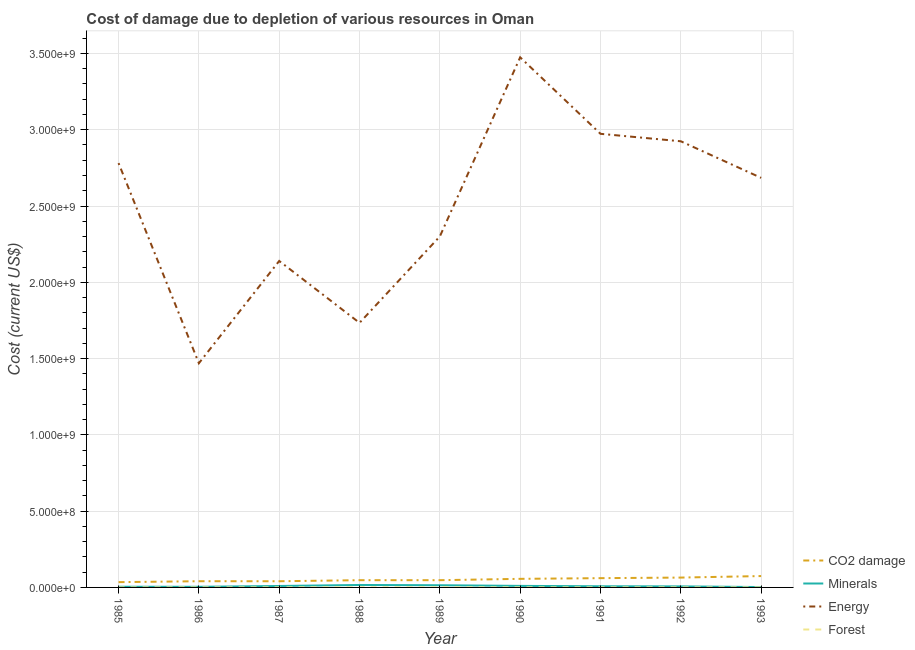How many different coloured lines are there?
Keep it short and to the point. 4. Does the line corresponding to cost of damage due to depletion of forests intersect with the line corresponding to cost of damage due to depletion of minerals?
Make the answer very short. No. What is the cost of damage due to depletion of energy in 1991?
Make the answer very short. 2.97e+09. Across all years, what is the maximum cost of damage due to depletion of minerals?
Make the answer very short. 1.61e+07. Across all years, what is the minimum cost of damage due to depletion of energy?
Offer a very short reply. 1.47e+09. In which year was the cost of damage due to depletion of coal maximum?
Make the answer very short. 1993. In which year was the cost of damage due to depletion of forests minimum?
Offer a terse response. 1985. What is the total cost of damage due to depletion of forests in the graph?
Your answer should be compact. 3.37e+06. What is the difference between the cost of damage due to depletion of energy in 1991 and that in 1993?
Make the answer very short. 2.89e+08. What is the difference between the cost of damage due to depletion of energy in 1993 and the cost of damage due to depletion of forests in 1986?
Give a very brief answer. 2.68e+09. What is the average cost of damage due to depletion of minerals per year?
Provide a succinct answer. 8.39e+06. In the year 1991, what is the difference between the cost of damage due to depletion of energy and cost of damage due to depletion of coal?
Provide a short and direct response. 2.91e+09. In how many years, is the cost of damage due to depletion of coal greater than 1200000000 US$?
Ensure brevity in your answer.  0. What is the ratio of the cost of damage due to depletion of minerals in 1986 to that in 1993?
Your answer should be very brief. 1.66. Is the cost of damage due to depletion of coal in 1985 less than that in 1988?
Your response must be concise. Yes. Is the difference between the cost of damage due to depletion of minerals in 1986 and 1988 greater than the difference between the cost of damage due to depletion of forests in 1986 and 1988?
Provide a short and direct response. No. What is the difference between the highest and the second highest cost of damage due to depletion of energy?
Provide a short and direct response. 5.01e+08. What is the difference between the highest and the lowest cost of damage due to depletion of forests?
Provide a succinct answer. 3.76e+05. In how many years, is the cost of damage due to depletion of minerals greater than the average cost of damage due to depletion of minerals taken over all years?
Make the answer very short. 4. Is it the case that in every year, the sum of the cost of damage due to depletion of coal and cost of damage due to depletion of minerals is greater than the cost of damage due to depletion of energy?
Your answer should be very brief. No. Is the cost of damage due to depletion of forests strictly greater than the cost of damage due to depletion of coal over the years?
Give a very brief answer. No. How many lines are there?
Make the answer very short. 4. How many years are there in the graph?
Provide a succinct answer. 9. Does the graph contain any zero values?
Offer a very short reply. No. How are the legend labels stacked?
Offer a terse response. Vertical. What is the title of the graph?
Provide a succinct answer. Cost of damage due to depletion of various resources in Oman . What is the label or title of the Y-axis?
Your response must be concise. Cost (current US$). What is the Cost (current US$) in CO2 damage in 1985?
Provide a succinct answer. 3.46e+07. What is the Cost (current US$) of Minerals in 1985?
Your response must be concise. 4.45e+06. What is the Cost (current US$) of Energy in 1985?
Give a very brief answer. 2.78e+09. What is the Cost (current US$) of Forest in 1985?
Give a very brief answer. 1.15e+05. What is the Cost (current US$) in CO2 damage in 1986?
Make the answer very short. 4.07e+07. What is the Cost (current US$) in Minerals in 1986?
Offer a terse response. 4.15e+06. What is the Cost (current US$) of Energy in 1986?
Provide a succinct answer. 1.47e+09. What is the Cost (current US$) in Forest in 1986?
Ensure brevity in your answer.  3.53e+05. What is the Cost (current US$) of CO2 damage in 1987?
Offer a terse response. 4.05e+07. What is the Cost (current US$) of Minerals in 1987?
Your answer should be very brief. 9.47e+06. What is the Cost (current US$) in Energy in 1987?
Offer a very short reply. 2.14e+09. What is the Cost (current US$) in Forest in 1987?
Provide a succinct answer. 3.85e+05. What is the Cost (current US$) of CO2 damage in 1988?
Provide a short and direct response. 4.74e+07. What is the Cost (current US$) of Minerals in 1988?
Your response must be concise. 1.61e+07. What is the Cost (current US$) in Energy in 1988?
Make the answer very short. 1.73e+09. What is the Cost (current US$) in Forest in 1988?
Your answer should be very brief. 4.10e+05. What is the Cost (current US$) in CO2 damage in 1989?
Keep it short and to the point. 4.74e+07. What is the Cost (current US$) in Minerals in 1989?
Provide a succinct answer. 1.43e+07. What is the Cost (current US$) of Energy in 1989?
Your response must be concise. 2.30e+09. What is the Cost (current US$) in Forest in 1989?
Offer a very short reply. 4.40e+05. What is the Cost (current US$) in CO2 damage in 1990?
Make the answer very short. 5.63e+07. What is the Cost (current US$) of Minerals in 1990?
Your answer should be very brief. 1.00e+07. What is the Cost (current US$) in Energy in 1990?
Your answer should be very brief. 3.47e+09. What is the Cost (current US$) of Forest in 1990?
Give a very brief answer. 4.68e+05. What is the Cost (current US$) of CO2 damage in 1991?
Keep it short and to the point. 6.08e+07. What is the Cost (current US$) of Minerals in 1991?
Ensure brevity in your answer.  7.56e+06. What is the Cost (current US$) of Energy in 1991?
Make the answer very short. 2.97e+09. What is the Cost (current US$) of Forest in 1991?
Provide a succinct answer. 4.91e+05. What is the Cost (current US$) of CO2 damage in 1992?
Offer a very short reply. 6.46e+07. What is the Cost (current US$) of Minerals in 1992?
Make the answer very short. 6.89e+06. What is the Cost (current US$) of Energy in 1992?
Make the answer very short. 2.92e+09. What is the Cost (current US$) in Forest in 1992?
Offer a very short reply. 3.79e+05. What is the Cost (current US$) of CO2 damage in 1993?
Keep it short and to the point. 7.45e+07. What is the Cost (current US$) in Minerals in 1993?
Your answer should be compact. 2.50e+06. What is the Cost (current US$) in Energy in 1993?
Offer a very short reply. 2.68e+09. What is the Cost (current US$) in Forest in 1993?
Give a very brief answer. 3.27e+05. Across all years, what is the maximum Cost (current US$) in CO2 damage?
Offer a terse response. 7.45e+07. Across all years, what is the maximum Cost (current US$) in Minerals?
Provide a short and direct response. 1.61e+07. Across all years, what is the maximum Cost (current US$) in Energy?
Make the answer very short. 3.47e+09. Across all years, what is the maximum Cost (current US$) in Forest?
Give a very brief answer. 4.91e+05. Across all years, what is the minimum Cost (current US$) in CO2 damage?
Give a very brief answer. 3.46e+07. Across all years, what is the minimum Cost (current US$) of Minerals?
Provide a short and direct response. 2.50e+06. Across all years, what is the minimum Cost (current US$) of Energy?
Give a very brief answer. 1.47e+09. Across all years, what is the minimum Cost (current US$) of Forest?
Provide a succinct answer. 1.15e+05. What is the total Cost (current US$) of CO2 damage in the graph?
Provide a short and direct response. 4.67e+08. What is the total Cost (current US$) in Minerals in the graph?
Keep it short and to the point. 7.55e+07. What is the total Cost (current US$) in Energy in the graph?
Give a very brief answer. 2.25e+1. What is the total Cost (current US$) in Forest in the graph?
Your answer should be compact. 3.37e+06. What is the difference between the Cost (current US$) in CO2 damage in 1985 and that in 1986?
Provide a short and direct response. -6.12e+06. What is the difference between the Cost (current US$) in Minerals in 1985 and that in 1986?
Your response must be concise. 3.06e+05. What is the difference between the Cost (current US$) of Energy in 1985 and that in 1986?
Keep it short and to the point. 1.31e+09. What is the difference between the Cost (current US$) of Forest in 1985 and that in 1986?
Provide a succinct answer. -2.37e+05. What is the difference between the Cost (current US$) in CO2 damage in 1985 and that in 1987?
Your response must be concise. -5.89e+06. What is the difference between the Cost (current US$) in Minerals in 1985 and that in 1987?
Offer a very short reply. -5.01e+06. What is the difference between the Cost (current US$) of Energy in 1985 and that in 1987?
Provide a short and direct response. 6.41e+08. What is the difference between the Cost (current US$) of Forest in 1985 and that in 1987?
Your answer should be very brief. -2.70e+05. What is the difference between the Cost (current US$) of CO2 damage in 1985 and that in 1988?
Your answer should be compact. -1.28e+07. What is the difference between the Cost (current US$) in Minerals in 1985 and that in 1988?
Keep it short and to the point. -1.17e+07. What is the difference between the Cost (current US$) in Energy in 1985 and that in 1988?
Ensure brevity in your answer.  1.05e+09. What is the difference between the Cost (current US$) of Forest in 1985 and that in 1988?
Give a very brief answer. -2.95e+05. What is the difference between the Cost (current US$) in CO2 damage in 1985 and that in 1989?
Keep it short and to the point. -1.28e+07. What is the difference between the Cost (current US$) of Minerals in 1985 and that in 1989?
Ensure brevity in your answer.  -9.88e+06. What is the difference between the Cost (current US$) in Energy in 1985 and that in 1989?
Your answer should be very brief. 4.81e+08. What is the difference between the Cost (current US$) in Forest in 1985 and that in 1989?
Your response must be concise. -3.25e+05. What is the difference between the Cost (current US$) in CO2 damage in 1985 and that in 1990?
Provide a short and direct response. -2.17e+07. What is the difference between the Cost (current US$) of Minerals in 1985 and that in 1990?
Your response must be concise. -5.58e+06. What is the difference between the Cost (current US$) of Energy in 1985 and that in 1990?
Your response must be concise. -6.93e+08. What is the difference between the Cost (current US$) of Forest in 1985 and that in 1990?
Ensure brevity in your answer.  -3.53e+05. What is the difference between the Cost (current US$) of CO2 damage in 1985 and that in 1991?
Make the answer very short. -2.62e+07. What is the difference between the Cost (current US$) of Minerals in 1985 and that in 1991?
Provide a succinct answer. -3.11e+06. What is the difference between the Cost (current US$) of Energy in 1985 and that in 1991?
Offer a terse response. -1.92e+08. What is the difference between the Cost (current US$) in Forest in 1985 and that in 1991?
Ensure brevity in your answer.  -3.76e+05. What is the difference between the Cost (current US$) in CO2 damage in 1985 and that in 1992?
Provide a succinct answer. -3.00e+07. What is the difference between the Cost (current US$) of Minerals in 1985 and that in 1992?
Give a very brief answer. -2.44e+06. What is the difference between the Cost (current US$) of Energy in 1985 and that in 1992?
Keep it short and to the point. -1.43e+08. What is the difference between the Cost (current US$) of Forest in 1985 and that in 1992?
Keep it short and to the point. -2.63e+05. What is the difference between the Cost (current US$) of CO2 damage in 1985 and that in 1993?
Offer a very short reply. -3.99e+07. What is the difference between the Cost (current US$) of Minerals in 1985 and that in 1993?
Offer a very short reply. 1.95e+06. What is the difference between the Cost (current US$) of Energy in 1985 and that in 1993?
Keep it short and to the point. 9.67e+07. What is the difference between the Cost (current US$) of Forest in 1985 and that in 1993?
Keep it short and to the point. -2.12e+05. What is the difference between the Cost (current US$) of CO2 damage in 1986 and that in 1987?
Ensure brevity in your answer.  2.28e+05. What is the difference between the Cost (current US$) in Minerals in 1986 and that in 1987?
Your response must be concise. -5.32e+06. What is the difference between the Cost (current US$) of Energy in 1986 and that in 1987?
Your answer should be compact. -6.70e+08. What is the difference between the Cost (current US$) in Forest in 1986 and that in 1987?
Keep it short and to the point. -3.24e+04. What is the difference between the Cost (current US$) of CO2 damage in 1986 and that in 1988?
Your response must be concise. -6.71e+06. What is the difference between the Cost (current US$) in Minerals in 1986 and that in 1988?
Provide a succinct answer. -1.20e+07. What is the difference between the Cost (current US$) of Energy in 1986 and that in 1988?
Offer a very short reply. -2.65e+08. What is the difference between the Cost (current US$) in Forest in 1986 and that in 1988?
Your answer should be very brief. -5.72e+04. What is the difference between the Cost (current US$) in CO2 damage in 1986 and that in 1989?
Your answer should be compact. -6.68e+06. What is the difference between the Cost (current US$) of Minerals in 1986 and that in 1989?
Your response must be concise. -1.02e+07. What is the difference between the Cost (current US$) of Energy in 1986 and that in 1989?
Offer a very short reply. -8.31e+08. What is the difference between the Cost (current US$) in Forest in 1986 and that in 1989?
Keep it short and to the point. -8.72e+04. What is the difference between the Cost (current US$) in CO2 damage in 1986 and that in 1990?
Your response must be concise. -1.55e+07. What is the difference between the Cost (current US$) in Minerals in 1986 and that in 1990?
Your answer should be very brief. -5.89e+06. What is the difference between the Cost (current US$) of Energy in 1986 and that in 1990?
Offer a terse response. -2.01e+09. What is the difference between the Cost (current US$) in Forest in 1986 and that in 1990?
Offer a very short reply. -1.15e+05. What is the difference between the Cost (current US$) in CO2 damage in 1986 and that in 1991?
Offer a very short reply. -2.01e+07. What is the difference between the Cost (current US$) in Minerals in 1986 and that in 1991?
Give a very brief answer. -3.42e+06. What is the difference between the Cost (current US$) of Energy in 1986 and that in 1991?
Give a very brief answer. -1.50e+09. What is the difference between the Cost (current US$) in Forest in 1986 and that in 1991?
Keep it short and to the point. -1.38e+05. What is the difference between the Cost (current US$) in CO2 damage in 1986 and that in 1992?
Keep it short and to the point. -2.38e+07. What is the difference between the Cost (current US$) in Minerals in 1986 and that in 1992?
Keep it short and to the point. -2.75e+06. What is the difference between the Cost (current US$) of Energy in 1986 and that in 1992?
Your response must be concise. -1.45e+09. What is the difference between the Cost (current US$) of Forest in 1986 and that in 1992?
Provide a succinct answer. -2.59e+04. What is the difference between the Cost (current US$) of CO2 damage in 1986 and that in 1993?
Offer a very short reply. -3.38e+07. What is the difference between the Cost (current US$) of Minerals in 1986 and that in 1993?
Your answer should be very brief. 1.64e+06. What is the difference between the Cost (current US$) of Energy in 1986 and that in 1993?
Provide a short and direct response. -1.22e+09. What is the difference between the Cost (current US$) of Forest in 1986 and that in 1993?
Ensure brevity in your answer.  2.54e+04. What is the difference between the Cost (current US$) in CO2 damage in 1987 and that in 1988?
Provide a short and direct response. -6.94e+06. What is the difference between the Cost (current US$) in Minerals in 1987 and that in 1988?
Provide a succinct answer. -6.67e+06. What is the difference between the Cost (current US$) in Energy in 1987 and that in 1988?
Provide a short and direct response. 4.06e+08. What is the difference between the Cost (current US$) in Forest in 1987 and that in 1988?
Ensure brevity in your answer.  -2.48e+04. What is the difference between the Cost (current US$) in CO2 damage in 1987 and that in 1989?
Provide a short and direct response. -6.91e+06. What is the difference between the Cost (current US$) in Minerals in 1987 and that in 1989?
Your response must be concise. -4.87e+06. What is the difference between the Cost (current US$) of Energy in 1987 and that in 1989?
Offer a very short reply. -1.61e+08. What is the difference between the Cost (current US$) in Forest in 1987 and that in 1989?
Provide a short and direct response. -5.48e+04. What is the difference between the Cost (current US$) in CO2 damage in 1987 and that in 1990?
Offer a terse response. -1.58e+07. What is the difference between the Cost (current US$) in Minerals in 1987 and that in 1990?
Give a very brief answer. -5.67e+05. What is the difference between the Cost (current US$) in Energy in 1987 and that in 1990?
Provide a short and direct response. -1.33e+09. What is the difference between the Cost (current US$) of Forest in 1987 and that in 1990?
Keep it short and to the point. -8.28e+04. What is the difference between the Cost (current US$) in CO2 damage in 1987 and that in 1991?
Provide a short and direct response. -2.03e+07. What is the difference between the Cost (current US$) in Minerals in 1987 and that in 1991?
Your response must be concise. 1.90e+06. What is the difference between the Cost (current US$) of Energy in 1987 and that in 1991?
Your response must be concise. -8.33e+08. What is the difference between the Cost (current US$) in Forest in 1987 and that in 1991?
Ensure brevity in your answer.  -1.06e+05. What is the difference between the Cost (current US$) of CO2 damage in 1987 and that in 1992?
Your response must be concise. -2.41e+07. What is the difference between the Cost (current US$) of Minerals in 1987 and that in 1992?
Provide a short and direct response. 2.57e+06. What is the difference between the Cost (current US$) of Energy in 1987 and that in 1992?
Provide a short and direct response. -7.84e+08. What is the difference between the Cost (current US$) of Forest in 1987 and that in 1992?
Make the answer very short. 6490.24. What is the difference between the Cost (current US$) of CO2 damage in 1987 and that in 1993?
Give a very brief answer. -3.40e+07. What is the difference between the Cost (current US$) of Minerals in 1987 and that in 1993?
Ensure brevity in your answer.  6.96e+06. What is the difference between the Cost (current US$) of Energy in 1987 and that in 1993?
Ensure brevity in your answer.  -5.45e+08. What is the difference between the Cost (current US$) in Forest in 1987 and that in 1993?
Give a very brief answer. 5.78e+04. What is the difference between the Cost (current US$) in CO2 damage in 1988 and that in 1989?
Provide a succinct answer. 2.90e+04. What is the difference between the Cost (current US$) in Minerals in 1988 and that in 1989?
Provide a short and direct response. 1.80e+06. What is the difference between the Cost (current US$) of Energy in 1988 and that in 1989?
Provide a succinct answer. -5.66e+08. What is the difference between the Cost (current US$) of Forest in 1988 and that in 1989?
Provide a short and direct response. -3.00e+04. What is the difference between the Cost (current US$) in CO2 damage in 1988 and that in 1990?
Your answer should be very brief. -8.83e+06. What is the difference between the Cost (current US$) in Minerals in 1988 and that in 1990?
Keep it short and to the point. 6.10e+06. What is the difference between the Cost (current US$) in Energy in 1988 and that in 1990?
Your answer should be very brief. -1.74e+09. What is the difference between the Cost (current US$) of Forest in 1988 and that in 1990?
Provide a short and direct response. -5.80e+04. What is the difference between the Cost (current US$) in CO2 damage in 1988 and that in 1991?
Ensure brevity in your answer.  -1.34e+07. What is the difference between the Cost (current US$) of Minerals in 1988 and that in 1991?
Provide a short and direct response. 8.57e+06. What is the difference between the Cost (current US$) of Energy in 1988 and that in 1991?
Give a very brief answer. -1.24e+09. What is the difference between the Cost (current US$) in Forest in 1988 and that in 1991?
Offer a terse response. -8.11e+04. What is the difference between the Cost (current US$) in CO2 damage in 1988 and that in 1992?
Your response must be concise. -1.71e+07. What is the difference between the Cost (current US$) in Minerals in 1988 and that in 1992?
Provide a short and direct response. 9.24e+06. What is the difference between the Cost (current US$) of Energy in 1988 and that in 1992?
Keep it short and to the point. -1.19e+09. What is the difference between the Cost (current US$) of Forest in 1988 and that in 1992?
Provide a succinct answer. 3.13e+04. What is the difference between the Cost (current US$) of CO2 damage in 1988 and that in 1993?
Offer a terse response. -2.71e+07. What is the difference between the Cost (current US$) in Minerals in 1988 and that in 1993?
Offer a very short reply. 1.36e+07. What is the difference between the Cost (current US$) in Energy in 1988 and that in 1993?
Offer a terse response. -9.50e+08. What is the difference between the Cost (current US$) of Forest in 1988 and that in 1993?
Offer a very short reply. 8.26e+04. What is the difference between the Cost (current US$) of CO2 damage in 1989 and that in 1990?
Keep it short and to the point. -8.85e+06. What is the difference between the Cost (current US$) in Minerals in 1989 and that in 1990?
Your answer should be compact. 4.30e+06. What is the difference between the Cost (current US$) of Energy in 1989 and that in 1990?
Give a very brief answer. -1.17e+09. What is the difference between the Cost (current US$) in Forest in 1989 and that in 1990?
Provide a short and direct response. -2.80e+04. What is the difference between the Cost (current US$) of CO2 damage in 1989 and that in 1991?
Keep it short and to the point. -1.34e+07. What is the difference between the Cost (current US$) in Minerals in 1989 and that in 1991?
Keep it short and to the point. 6.77e+06. What is the difference between the Cost (current US$) of Energy in 1989 and that in 1991?
Provide a short and direct response. -6.73e+08. What is the difference between the Cost (current US$) of Forest in 1989 and that in 1991?
Provide a short and direct response. -5.11e+04. What is the difference between the Cost (current US$) of CO2 damage in 1989 and that in 1992?
Provide a succinct answer. -1.72e+07. What is the difference between the Cost (current US$) of Minerals in 1989 and that in 1992?
Your answer should be very brief. 7.44e+06. What is the difference between the Cost (current US$) in Energy in 1989 and that in 1992?
Your answer should be compact. -6.24e+08. What is the difference between the Cost (current US$) in Forest in 1989 and that in 1992?
Offer a very short reply. 6.13e+04. What is the difference between the Cost (current US$) of CO2 damage in 1989 and that in 1993?
Give a very brief answer. -2.71e+07. What is the difference between the Cost (current US$) in Minerals in 1989 and that in 1993?
Give a very brief answer. 1.18e+07. What is the difference between the Cost (current US$) in Energy in 1989 and that in 1993?
Offer a terse response. -3.84e+08. What is the difference between the Cost (current US$) of Forest in 1989 and that in 1993?
Offer a terse response. 1.13e+05. What is the difference between the Cost (current US$) in CO2 damage in 1990 and that in 1991?
Offer a very short reply. -4.55e+06. What is the difference between the Cost (current US$) in Minerals in 1990 and that in 1991?
Keep it short and to the point. 2.47e+06. What is the difference between the Cost (current US$) of Energy in 1990 and that in 1991?
Your answer should be very brief. 5.01e+08. What is the difference between the Cost (current US$) of Forest in 1990 and that in 1991?
Ensure brevity in your answer.  -2.31e+04. What is the difference between the Cost (current US$) of CO2 damage in 1990 and that in 1992?
Your response must be concise. -8.31e+06. What is the difference between the Cost (current US$) of Minerals in 1990 and that in 1992?
Make the answer very short. 3.14e+06. What is the difference between the Cost (current US$) in Energy in 1990 and that in 1992?
Offer a terse response. 5.50e+08. What is the difference between the Cost (current US$) of Forest in 1990 and that in 1992?
Your response must be concise. 8.93e+04. What is the difference between the Cost (current US$) in CO2 damage in 1990 and that in 1993?
Your answer should be very brief. -1.83e+07. What is the difference between the Cost (current US$) in Minerals in 1990 and that in 1993?
Offer a terse response. 7.53e+06. What is the difference between the Cost (current US$) in Energy in 1990 and that in 1993?
Provide a succinct answer. 7.90e+08. What is the difference between the Cost (current US$) of Forest in 1990 and that in 1993?
Provide a succinct answer. 1.41e+05. What is the difference between the Cost (current US$) of CO2 damage in 1991 and that in 1992?
Keep it short and to the point. -3.76e+06. What is the difference between the Cost (current US$) in Minerals in 1991 and that in 1992?
Ensure brevity in your answer.  6.69e+05. What is the difference between the Cost (current US$) in Energy in 1991 and that in 1992?
Your response must be concise. 4.89e+07. What is the difference between the Cost (current US$) in Forest in 1991 and that in 1992?
Ensure brevity in your answer.  1.12e+05. What is the difference between the Cost (current US$) in CO2 damage in 1991 and that in 1993?
Give a very brief answer. -1.37e+07. What is the difference between the Cost (current US$) in Minerals in 1991 and that in 1993?
Your answer should be compact. 5.06e+06. What is the difference between the Cost (current US$) in Energy in 1991 and that in 1993?
Provide a short and direct response. 2.89e+08. What is the difference between the Cost (current US$) in Forest in 1991 and that in 1993?
Ensure brevity in your answer.  1.64e+05. What is the difference between the Cost (current US$) in CO2 damage in 1992 and that in 1993?
Your response must be concise. -9.95e+06. What is the difference between the Cost (current US$) of Minerals in 1992 and that in 1993?
Give a very brief answer. 4.39e+06. What is the difference between the Cost (current US$) in Energy in 1992 and that in 1993?
Keep it short and to the point. 2.40e+08. What is the difference between the Cost (current US$) of Forest in 1992 and that in 1993?
Your answer should be very brief. 5.13e+04. What is the difference between the Cost (current US$) of CO2 damage in 1985 and the Cost (current US$) of Minerals in 1986?
Your answer should be compact. 3.05e+07. What is the difference between the Cost (current US$) in CO2 damage in 1985 and the Cost (current US$) in Energy in 1986?
Keep it short and to the point. -1.43e+09. What is the difference between the Cost (current US$) of CO2 damage in 1985 and the Cost (current US$) of Forest in 1986?
Offer a very short reply. 3.43e+07. What is the difference between the Cost (current US$) in Minerals in 1985 and the Cost (current US$) in Energy in 1986?
Your response must be concise. -1.47e+09. What is the difference between the Cost (current US$) in Minerals in 1985 and the Cost (current US$) in Forest in 1986?
Your answer should be compact. 4.10e+06. What is the difference between the Cost (current US$) in Energy in 1985 and the Cost (current US$) in Forest in 1986?
Keep it short and to the point. 2.78e+09. What is the difference between the Cost (current US$) of CO2 damage in 1985 and the Cost (current US$) of Minerals in 1987?
Give a very brief answer. 2.51e+07. What is the difference between the Cost (current US$) of CO2 damage in 1985 and the Cost (current US$) of Energy in 1987?
Your answer should be compact. -2.11e+09. What is the difference between the Cost (current US$) of CO2 damage in 1985 and the Cost (current US$) of Forest in 1987?
Provide a short and direct response. 3.42e+07. What is the difference between the Cost (current US$) in Minerals in 1985 and the Cost (current US$) in Energy in 1987?
Offer a terse response. -2.14e+09. What is the difference between the Cost (current US$) of Minerals in 1985 and the Cost (current US$) of Forest in 1987?
Ensure brevity in your answer.  4.07e+06. What is the difference between the Cost (current US$) of Energy in 1985 and the Cost (current US$) of Forest in 1987?
Your answer should be very brief. 2.78e+09. What is the difference between the Cost (current US$) in CO2 damage in 1985 and the Cost (current US$) in Minerals in 1988?
Give a very brief answer. 1.85e+07. What is the difference between the Cost (current US$) in CO2 damage in 1985 and the Cost (current US$) in Energy in 1988?
Offer a terse response. -1.70e+09. What is the difference between the Cost (current US$) in CO2 damage in 1985 and the Cost (current US$) in Forest in 1988?
Your answer should be very brief. 3.42e+07. What is the difference between the Cost (current US$) in Minerals in 1985 and the Cost (current US$) in Energy in 1988?
Ensure brevity in your answer.  -1.73e+09. What is the difference between the Cost (current US$) in Minerals in 1985 and the Cost (current US$) in Forest in 1988?
Give a very brief answer. 4.04e+06. What is the difference between the Cost (current US$) in Energy in 1985 and the Cost (current US$) in Forest in 1988?
Your response must be concise. 2.78e+09. What is the difference between the Cost (current US$) in CO2 damage in 1985 and the Cost (current US$) in Minerals in 1989?
Make the answer very short. 2.03e+07. What is the difference between the Cost (current US$) in CO2 damage in 1985 and the Cost (current US$) in Energy in 1989?
Give a very brief answer. -2.27e+09. What is the difference between the Cost (current US$) in CO2 damage in 1985 and the Cost (current US$) in Forest in 1989?
Ensure brevity in your answer.  3.42e+07. What is the difference between the Cost (current US$) of Minerals in 1985 and the Cost (current US$) of Energy in 1989?
Offer a very short reply. -2.30e+09. What is the difference between the Cost (current US$) of Minerals in 1985 and the Cost (current US$) of Forest in 1989?
Ensure brevity in your answer.  4.01e+06. What is the difference between the Cost (current US$) of Energy in 1985 and the Cost (current US$) of Forest in 1989?
Your answer should be very brief. 2.78e+09. What is the difference between the Cost (current US$) in CO2 damage in 1985 and the Cost (current US$) in Minerals in 1990?
Keep it short and to the point. 2.46e+07. What is the difference between the Cost (current US$) in CO2 damage in 1985 and the Cost (current US$) in Energy in 1990?
Make the answer very short. -3.44e+09. What is the difference between the Cost (current US$) of CO2 damage in 1985 and the Cost (current US$) of Forest in 1990?
Your answer should be very brief. 3.41e+07. What is the difference between the Cost (current US$) of Minerals in 1985 and the Cost (current US$) of Energy in 1990?
Provide a short and direct response. -3.47e+09. What is the difference between the Cost (current US$) of Minerals in 1985 and the Cost (current US$) of Forest in 1990?
Offer a very short reply. 3.98e+06. What is the difference between the Cost (current US$) of Energy in 1985 and the Cost (current US$) of Forest in 1990?
Ensure brevity in your answer.  2.78e+09. What is the difference between the Cost (current US$) of CO2 damage in 1985 and the Cost (current US$) of Minerals in 1991?
Give a very brief answer. 2.70e+07. What is the difference between the Cost (current US$) of CO2 damage in 1985 and the Cost (current US$) of Energy in 1991?
Your answer should be compact. -2.94e+09. What is the difference between the Cost (current US$) in CO2 damage in 1985 and the Cost (current US$) in Forest in 1991?
Your response must be concise. 3.41e+07. What is the difference between the Cost (current US$) of Minerals in 1985 and the Cost (current US$) of Energy in 1991?
Your response must be concise. -2.97e+09. What is the difference between the Cost (current US$) in Minerals in 1985 and the Cost (current US$) in Forest in 1991?
Provide a short and direct response. 3.96e+06. What is the difference between the Cost (current US$) of Energy in 1985 and the Cost (current US$) of Forest in 1991?
Your response must be concise. 2.78e+09. What is the difference between the Cost (current US$) of CO2 damage in 1985 and the Cost (current US$) of Minerals in 1992?
Your response must be concise. 2.77e+07. What is the difference between the Cost (current US$) of CO2 damage in 1985 and the Cost (current US$) of Energy in 1992?
Provide a succinct answer. -2.89e+09. What is the difference between the Cost (current US$) in CO2 damage in 1985 and the Cost (current US$) in Forest in 1992?
Keep it short and to the point. 3.42e+07. What is the difference between the Cost (current US$) of Minerals in 1985 and the Cost (current US$) of Energy in 1992?
Your answer should be very brief. -2.92e+09. What is the difference between the Cost (current US$) of Minerals in 1985 and the Cost (current US$) of Forest in 1992?
Offer a very short reply. 4.07e+06. What is the difference between the Cost (current US$) of Energy in 1985 and the Cost (current US$) of Forest in 1992?
Offer a very short reply. 2.78e+09. What is the difference between the Cost (current US$) in CO2 damage in 1985 and the Cost (current US$) in Minerals in 1993?
Make the answer very short. 3.21e+07. What is the difference between the Cost (current US$) in CO2 damage in 1985 and the Cost (current US$) in Energy in 1993?
Your answer should be compact. -2.65e+09. What is the difference between the Cost (current US$) in CO2 damage in 1985 and the Cost (current US$) in Forest in 1993?
Keep it short and to the point. 3.43e+07. What is the difference between the Cost (current US$) in Minerals in 1985 and the Cost (current US$) in Energy in 1993?
Offer a very short reply. -2.68e+09. What is the difference between the Cost (current US$) in Minerals in 1985 and the Cost (current US$) in Forest in 1993?
Your response must be concise. 4.12e+06. What is the difference between the Cost (current US$) of Energy in 1985 and the Cost (current US$) of Forest in 1993?
Ensure brevity in your answer.  2.78e+09. What is the difference between the Cost (current US$) in CO2 damage in 1986 and the Cost (current US$) in Minerals in 1987?
Your response must be concise. 3.13e+07. What is the difference between the Cost (current US$) in CO2 damage in 1986 and the Cost (current US$) in Energy in 1987?
Make the answer very short. -2.10e+09. What is the difference between the Cost (current US$) of CO2 damage in 1986 and the Cost (current US$) of Forest in 1987?
Keep it short and to the point. 4.03e+07. What is the difference between the Cost (current US$) in Minerals in 1986 and the Cost (current US$) in Energy in 1987?
Make the answer very short. -2.14e+09. What is the difference between the Cost (current US$) in Minerals in 1986 and the Cost (current US$) in Forest in 1987?
Provide a short and direct response. 3.76e+06. What is the difference between the Cost (current US$) in Energy in 1986 and the Cost (current US$) in Forest in 1987?
Your answer should be very brief. 1.47e+09. What is the difference between the Cost (current US$) of CO2 damage in 1986 and the Cost (current US$) of Minerals in 1988?
Your answer should be very brief. 2.46e+07. What is the difference between the Cost (current US$) of CO2 damage in 1986 and the Cost (current US$) of Energy in 1988?
Give a very brief answer. -1.69e+09. What is the difference between the Cost (current US$) in CO2 damage in 1986 and the Cost (current US$) in Forest in 1988?
Provide a succinct answer. 4.03e+07. What is the difference between the Cost (current US$) of Minerals in 1986 and the Cost (current US$) of Energy in 1988?
Give a very brief answer. -1.73e+09. What is the difference between the Cost (current US$) of Minerals in 1986 and the Cost (current US$) of Forest in 1988?
Keep it short and to the point. 3.74e+06. What is the difference between the Cost (current US$) in Energy in 1986 and the Cost (current US$) in Forest in 1988?
Keep it short and to the point. 1.47e+09. What is the difference between the Cost (current US$) of CO2 damage in 1986 and the Cost (current US$) of Minerals in 1989?
Give a very brief answer. 2.64e+07. What is the difference between the Cost (current US$) in CO2 damage in 1986 and the Cost (current US$) in Energy in 1989?
Provide a short and direct response. -2.26e+09. What is the difference between the Cost (current US$) of CO2 damage in 1986 and the Cost (current US$) of Forest in 1989?
Ensure brevity in your answer.  4.03e+07. What is the difference between the Cost (current US$) of Minerals in 1986 and the Cost (current US$) of Energy in 1989?
Ensure brevity in your answer.  -2.30e+09. What is the difference between the Cost (current US$) of Minerals in 1986 and the Cost (current US$) of Forest in 1989?
Give a very brief answer. 3.71e+06. What is the difference between the Cost (current US$) of Energy in 1986 and the Cost (current US$) of Forest in 1989?
Give a very brief answer. 1.47e+09. What is the difference between the Cost (current US$) of CO2 damage in 1986 and the Cost (current US$) of Minerals in 1990?
Offer a terse response. 3.07e+07. What is the difference between the Cost (current US$) in CO2 damage in 1986 and the Cost (current US$) in Energy in 1990?
Give a very brief answer. -3.43e+09. What is the difference between the Cost (current US$) in CO2 damage in 1986 and the Cost (current US$) in Forest in 1990?
Provide a succinct answer. 4.03e+07. What is the difference between the Cost (current US$) in Minerals in 1986 and the Cost (current US$) in Energy in 1990?
Ensure brevity in your answer.  -3.47e+09. What is the difference between the Cost (current US$) in Minerals in 1986 and the Cost (current US$) in Forest in 1990?
Give a very brief answer. 3.68e+06. What is the difference between the Cost (current US$) of Energy in 1986 and the Cost (current US$) of Forest in 1990?
Offer a terse response. 1.47e+09. What is the difference between the Cost (current US$) of CO2 damage in 1986 and the Cost (current US$) of Minerals in 1991?
Your answer should be compact. 3.32e+07. What is the difference between the Cost (current US$) in CO2 damage in 1986 and the Cost (current US$) in Energy in 1991?
Offer a very short reply. -2.93e+09. What is the difference between the Cost (current US$) in CO2 damage in 1986 and the Cost (current US$) in Forest in 1991?
Keep it short and to the point. 4.02e+07. What is the difference between the Cost (current US$) in Minerals in 1986 and the Cost (current US$) in Energy in 1991?
Your response must be concise. -2.97e+09. What is the difference between the Cost (current US$) of Minerals in 1986 and the Cost (current US$) of Forest in 1991?
Your answer should be very brief. 3.66e+06. What is the difference between the Cost (current US$) of Energy in 1986 and the Cost (current US$) of Forest in 1991?
Provide a succinct answer. 1.47e+09. What is the difference between the Cost (current US$) in CO2 damage in 1986 and the Cost (current US$) in Minerals in 1992?
Provide a succinct answer. 3.38e+07. What is the difference between the Cost (current US$) in CO2 damage in 1986 and the Cost (current US$) in Energy in 1992?
Your response must be concise. -2.88e+09. What is the difference between the Cost (current US$) in CO2 damage in 1986 and the Cost (current US$) in Forest in 1992?
Keep it short and to the point. 4.03e+07. What is the difference between the Cost (current US$) of Minerals in 1986 and the Cost (current US$) of Energy in 1992?
Keep it short and to the point. -2.92e+09. What is the difference between the Cost (current US$) of Minerals in 1986 and the Cost (current US$) of Forest in 1992?
Give a very brief answer. 3.77e+06. What is the difference between the Cost (current US$) of Energy in 1986 and the Cost (current US$) of Forest in 1992?
Make the answer very short. 1.47e+09. What is the difference between the Cost (current US$) of CO2 damage in 1986 and the Cost (current US$) of Minerals in 1993?
Offer a terse response. 3.82e+07. What is the difference between the Cost (current US$) in CO2 damage in 1986 and the Cost (current US$) in Energy in 1993?
Ensure brevity in your answer.  -2.64e+09. What is the difference between the Cost (current US$) in CO2 damage in 1986 and the Cost (current US$) in Forest in 1993?
Offer a terse response. 4.04e+07. What is the difference between the Cost (current US$) of Minerals in 1986 and the Cost (current US$) of Energy in 1993?
Ensure brevity in your answer.  -2.68e+09. What is the difference between the Cost (current US$) in Minerals in 1986 and the Cost (current US$) in Forest in 1993?
Your answer should be very brief. 3.82e+06. What is the difference between the Cost (current US$) in Energy in 1986 and the Cost (current US$) in Forest in 1993?
Make the answer very short. 1.47e+09. What is the difference between the Cost (current US$) of CO2 damage in 1987 and the Cost (current US$) of Minerals in 1988?
Make the answer very short. 2.44e+07. What is the difference between the Cost (current US$) of CO2 damage in 1987 and the Cost (current US$) of Energy in 1988?
Provide a succinct answer. -1.69e+09. What is the difference between the Cost (current US$) of CO2 damage in 1987 and the Cost (current US$) of Forest in 1988?
Provide a succinct answer. 4.01e+07. What is the difference between the Cost (current US$) in Minerals in 1987 and the Cost (current US$) in Energy in 1988?
Offer a very short reply. -1.72e+09. What is the difference between the Cost (current US$) of Minerals in 1987 and the Cost (current US$) of Forest in 1988?
Give a very brief answer. 9.06e+06. What is the difference between the Cost (current US$) of Energy in 1987 and the Cost (current US$) of Forest in 1988?
Provide a short and direct response. 2.14e+09. What is the difference between the Cost (current US$) in CO2 damage in 1987 and the Cost (current US$) in Minerals in 1989?
Provide a short and direct response. 2.62e+07. What is the difference between the Cost (current US$) in CO2 damage in 1987 and the Cost (current US$) in Energy in 1989?
Your answer should be compact. -2.26e+09. What is the difference between the Cost (current US$) of CO2 damage in 1987 and the Cost (current US$) of Forest in 1989?
Give a very brief answer. 4.01e+07. What is the difference between the Cost (current US$) of Minerals in 1987 and the Cost (current US$) of Energy in 1989?
Your answer should be compact. -2.29e+09. What is the difference between the Cost (current US$) in Minerals in 1987 and the Cost (current US$) in Forest in 1989?
Offer a terse response. 9.03e+06. What is the difference between the Cost (current US$) in Energy in 1987 and the Cost (current US$) in Forest in 1989?
Ensure brevity in your answer.  2.14e+09. What is the difference between the Cost (current US$) of CO2 damage in 1987 and the Cost (current US$) of Minerals in 1990?
Offer a terse response. 3.05e+07. What is the difference between the Cost (current US$) of CO2 damage in 1987 and the Cost (current US$) of Energy in 1990?
Your answer should be very brief. -3.43e+09. What is the difference between the Cost (current US$) in CO2 damage in 1987 and the Cost (current US$) in Forest in 1990?
Make the answer very short. 4.00e+07. What is the difference between the Cost (current US$) in Minerals in 1987 and the Cost (current US$) in Energy in 1990?
Your answer should be compact. -3.47e+09. What is the difference between the Cost (current US$) of Minerals in 1987 and the Cost (current US$) of Forest in 1990?
Make the answer very short. 9.00e+06. What is the difference between the Cost (current US$) in Energy in 1987 and the Cost (current US$) in Forest in 1990?
Keep it short and to the point. 2.14e+09. What is the difference between the Cost (current US$) in CO2 damage in 1987 and the Cost (current US$) in Minerals in 1991?
Keep it short and to the point. 3.29e+07. What is the difference between the Cost (current US$) in CO2 damage in 1987 and the Cost (current US$) in Energy in 1991?
Provide a succinct answer. -2.93e+09. What is the difference between the Cost (current US$) in CO2 damage in 1987 and the Cost (current US$) in Forest in 1991?
Give a very brief answer. 4.00e+07. What is the difference between the Cost (current US$) of Minerals in 1987 and the Cost (current US$) of Energy in 1991?
Your answer should be compact. -2.96e+09. What is the difference between the Cost (current US$) of Minerals in 1987 and the Cost (current US$) of Forest in 1991?
Make the answer very short. 8.97e+06. What is the difference between the Cost (current US$) of Energy in 1987 and the Cost (current US$) of Forest in 1991?
Keep it short and to the point. 2.14e+09. What is the difference between the Cost (current US$) in CO2 damage in 1987 and the Cost (current US$) in Minerals in 1992?
Offer a terse response. 3.36e+07. What is the difference between the Cost (current US$) of CO2 damage in 1987 and the Cost (current US$) of Energy in 1992?
Your answer should be very brief. -2.88e+09. What is the difference between the Cost (current US$) of CO2 damage in 1987 and the Cost (current US$) of Forest in 1992?
Your response must be concise. 4.01e+07. What is the difference between the Cost (current US$) of Minerals in 1987 and the Cost (current US$) of Energy in 1992?
Offer a terse response. -2.91e+09. What is the difference between the Cost (current US$) in Minerals in 1987 and the Cost (current US$) in Forest in 1992?
Your answer should be very brief. 9.09e+06. What is the difference between the Cost (current US$) of Energy in 1987 and the Cost (current US$) of Forest in 1992?
Offer a terse response. 2.14e+09. What is the difference between the Cost (current US$) in CO2 damage in 1987 and the Cost (current US$) in Minerals in 1993?
Offer a very short reply. 3.80e+07. What is the difference between the Cost (current US$) of CO2 damage in 1987 and the Cost (current US$) of Energy in 1993?
Keep it short and to the point. -2.64e+09. What is the difference between the Cost (current US$) of CO2 damage in 1987 and the Cost (current US$) of Forest in 1993?
Give a very brief answer. 4.02e+07. What is the difference between the Cost (current US$) of Minerals in 1987 and the Cost (current US$) of Energy in 1993?
Provide a succinct answer. -2.68e+09. What is the difference between the Cost (current US$) of Minerals in 1987 and the Cost (current US$) of Forest in 1993?
Your answer should be very brief. 9.14e+06. What is the difference between the Cost (current US$) of Energy in 1987 and the Cost (current US$) of Forest in 1993?
Ensure brevity in your answer.  2.14e+09. What is the difference between the Cost (current US$) of CO2 damage in 1988 and the Cost (current US$) of Minerals in 1989?
Give a very brief answer. 3.31e+07. What is the difference between the Cost (current US$) of CO2 damage in 1988 and the Cost (current US$) of Energy in 1989?
Provide a short and direct response. -2.25e+09. What is the difference between the Cost (current US$) in CO2 damage in 1988 and the Cost (current US$) in Forest in 1989?
Provide a succinct answer. 4.70e+07. What is the difference between the Cost (current US$) in Minerals in 1988 and the Cost (current US$) in Energy in 1989?
Give a very brief answer. -2.28e+09. What is the difference between the Cost (current US$) of Minerals in 1988 and the Cost (current US$) of Forest in 1989?
Ensure brevity in your answer.  1.57e+07. What is the difference between the Cost (current US$) in Energy in 1988 and the Cost (current US$) in Forest in 1989?
Provide a short and direct response. 1.73e+09. What is the difference between the Cost (current US$) of CO2 damage in 1988 and the Cost (current US$) of Minerals in 1990?
Offer a terse response. 3.74e+07. What is the difference between the Cost (current US$) in CO2 damage in 1988 and the Cost (current US$) in Energy in 1990?
Give a very brief answer. -3.43e+09. What is the difference between the Cost (current US$) in CO2 damage in 1988 and the Cost (current US$) in Forest in 1990?
Your answer should be very brief. 4.70e+07. What is the difference between the Cost (current US$) in Minerals in 1988 and the Cost (current US$) in Energy in 1990?
Provide a short and direct response. -3.46e+09. What is the difference between the Cost (current US$) of Minerals in 1988 and the Cost (current US$) of Forest in 1990?
Offer a terse response. 1.57e+07. What is the difference between the Cost (current US$) in Energy in 1988 and the Cost (current US$) in Forest in 1990?
Give a very brief answer. 1.73e+09. What is the difference between the Cost (current US$) in CO2 damage in 1988 and the Cost (current US$) in Minerals in 1991?
Make the answer very short. 3.99e+07. What is the difference between the Cost (current US$) of CO2 damage in 1988 and the Cost (current US$) of Energy in 1991?
Keep it short and to the point. -2.93e+09. What is the difference between the Cost (current US$) of CO2 damage in 1988 and the Cost (current US$) of Forest in 1991?
Give a very brief answer. 4.69e+07. What is the difference between the Cost (current US$) in Minerals in 1988 and the Cost (current US$) in Energy in 1991?
Ensure brevity in your answer.  -2.96e+09. What is the difference between the Cost (current US$) of Minerals in 1988 and the Cost (current US$) of Forest in 1991?
Offer a very short reply. 1.56e+07. What is the difference between the Cost (current US$) in Energy in 1988 and the Cost (current US$) in Forest in 1991?
Your response must be concise. 1.73e+09. What is the difference between the Cost (current US$) of CO2 damage in 1988 and the Cost (current US$) of Minerals in 1992?
Provide a succinct answer. 4.05e+07. What is the difference between the Cost (current US$) in CO2 damage in 1988 and the Cost (current US$) in Energy in 1992?
Your answer should be very brief. -2.88e+09. What is the difference between the Cost (current US$) in CO2 damage in 1988 and the Cost (current US$) in Forest in 1992?
Your answer should be compact. 4.71e+07. What is the difference between the Cost (current US$) in Minerals in 1988 and the Cost (current US$) in Energy in 1992?
Keep it short and to the point. -2.91e+09. What is the difference between the Cost (current US$) in Minerals in 1988 and the Cost (current US$) in Forest in 1992?
Offer a very short reply. 1.58e+07. What is the difference between the Cost (current US$) in Energy in 1988 and the Cost (current US$) in Forest in 1992?
Ensure brevity in your answer.  1.73e+09. What is the difference between the Cost (current US$) of CO2 damage in 1988 and the Cost (current US$) of Minerals in 1993?
Offer a very short reply. 4.49e+07. What is the difference between the Cost (current US$) of CO2 damage in 1988 and the Cost (current US$) of Energy in 1993?
Provide a succinct answer. -2.64e+09. What is the difference between the Cost (current US$) in CO2 damage in 1988 and the Cost (current US$) in Forest in 1993?
Ensure brevity in your answer.  4.71e+07. What is the difference between the Cost (current US$) in Minerals in 1988 and the Cost (current US$) in Energy in 1993?
Offer a very short reply. -2.67e+09. What is the difference between the Cost (current US$) of Minerals in 1988 and the Cost (current US$) of Forest in 1993?
Your answer should be compact. 1.58e+07. What is the difference between the Cost (current US$) in Energy in 1988 and the Cost (current US$) in Forest in 1993?
Provide a succinct answer. 1.73e+09. What is the difference between the Cost (current US$) in CO2 damage in 1989 and the Cost (current US$) in Minerals in 1990?
Offer a very short reply. 3.74e+07. What is the difference between the Cost (current US$) in CO2 damage in 1989 and the Cost (current US$) in Energy in 1990?
Ensure brevity in your answer.  -3.43e+09. What is the difference between the Cost (current US$) of CO2 damage in 1989 and the Cost (current US$) of Forest in 1990?
Your response must be concise. 4.69e+07. What is the difference between the Cost (current US$) in Minerals in 1989 and the Cost (current US$) in Energy in 1990?
Provide a short and direct response. -3.46e+09. What is the difference between the Cost (current US$) in Minerals in 1989 and the Cost (current US$) in Forest in 1990?
Provide a succinct answer. 1.39e+07. What is the difference between the Cost (current US$) in Energy in 1989 and the Cost (current US$) in Forest in 1990?
Your answer should be compact. 2.30e+09. What is the difference between the Cost (current US$) of CO2 damage in 1989 and the Cost (current US$) of Minerals in 1991?
Offer a very short reply. 3.98e+07. What is the difference between the Cost (current US$) of CO2 damage in 1989 and the Cost (current US$) of Energy in 1991?
Your answer should be very brief. -2.93e+09. What is the difference between the Cost (current US$) in CO2 damage in 1989 and the Cost (current US$) in Forest in 1991?
Your answer should be very brief. 4.69e+07. What is the difference between the Cost (current US$) in Minerals in 1989 and the Cost (current US$) in Energy in 1991?
Provide a short and direct response. -2.96e+09. What is the difference between the Cost (current US$) of Minerals in 1989 and the Cost (current US$) of Forest in 1991?
Make the answer very short. 1.38e+07. What is the difference between the Cost (current US$) in Energy in 1989 and the Cost (current US$) in Forest in 1991?
Your response must be concise. 2.30e+09. What is the difference between the Cost (current US$) of CO2 damage in 1989 and the Cost (current US$) of Minerals in 1992?
Ensure brevity in your answer.  4.05e+07. What is the difference between the Cost (current US$) in CO2 damage in 1989 and the Cost (current US$) in Energy in 1992?
Offer a terse response. -2.88e+09. What is the difference between the Cost (current US$) of CO2 damage in 1989 and the Cost (current US$) of Forest in 1992?
Your response must be concise. 4.70e+07. What is the difference between the Cost (current US$) of Minerals in 1989 and the Cost (current US$) of Energy in 1992?
Ensure brevity in your answer.  -2.91e+09. What is the difference between the Cost (current US$) in Minerals in 1989 and the Cost (current US$) in Forest in 1992?
Your answer should be compact. 1.40e+07. What is the difference between the Cost (current US$) of Energy in 1989 and the Cost (current US$) of Forest in 1992?
Ensure brevity in your answer.  2.30e+09. What is the difference between the Cost (current US$) in CO2 damage in 1989 and the Cost (current US$) in Minerals in 1993?
Make the answer very short. 4.49e+07. What is the difference between the Cost (current US$) of CO2 damage in 1989 and the Cost (current US$) of Energy in 1993?
Ensure brevity in your answer.  -2.64e+09. What is the difference between the Cost (current US$) in CO2 damage in 1989 and the Cost (current US$) in Forest in 1993?
Make the answer very short. 4.71e+07. What is the difference between the Cost (current US$) of Minerals in 1989 and the Cost (current US$) of Energy in 1993?
Keep it short and to the point. -2.67e+09. What is the difference between the Cost (current US$) of Minerals in 1989 and the Cost (current US$) of Forest in 1993?
Your response must be concise. 1.40e+07. What is the difference between the Cost (current US$) in Energy in 1989 and the Cost (current US$) in Forest in 1993?
Make the answer very short. 2.30e+09. What is the difference between the Cost (current US$) in CO2 damage in 1990 and the Cost (current US$) in Minerals in 1991?
Keep it short and to the point. 4.87e+07. What is the difference between the Cost (current US$) of CO2 damage in 1990 and the Cost (current US$) of Energy in 1991?
Your response must be concise. -2.92e+09. What is the difference between the Cost (current US$) of CO2 damage in 1990 and the Cost (current US$) of Forest in 1991?
Your response must be concise. 5.58e+07. What is the difference between the Cost (current US$) in Minerals in 1990 and the Cost (current US$) in Energy in 1991?
Your response must be concise. -2.96e+09. What is the difference between the Cost (current US$) in Minerals in 1990 and the Cost (current US$) in Forest in 1991?
Give a very brief answer. 9.54e+06. What is the difference between the Cost (current US$) in Energy in 1990 and the Cost (current US$) in Forest in 1991?
Your response must be concise. 3.47e+09. What is the difference between the Cost (current US$) in CO2 damage in 1990 and the Cost (current US$) in Minerals in 1992?
Your answer should be very brief. 4.94e+07. What is the difference between the Cost (current US$) in CO2 damage in 1990 and the Cost (current US$) in Energy in 1992?
Make the answer very short. -2.87e+09. What is the difference between the Cost (current US$) in CO2 damage in 1990 and the Cost (current US$) in Forest in 1992?
Keep it short and to the point. 5.59e+07. What is the difference between the Cost (current US$) in Minerals in 1990 and the Cost (current US$) in Energy in 1992?
Give a very brief answer. -2.91e+09. What is the difference between the Cost (current US$) of Minerals in 1990 and the Cost (current US$) of Forest in 1992?
Your response must be concise. 9.65e+06. What is the difference between the Cost (current US$) of Energy in 1990 and the Cost (current US$) of Forest in 1992?
Your response must be concise. 3.47e+09. What is the difference between the Cost (current US$) of CO2 damage in 1990 and the Cost (current US$) of Minerals in 1993?
Provide a short and direct response. 5.38e+07. What is the difference between the Cost (current US$) of CO2 damage in 1990 and the Cost (current US$) of Energy in 1993?
Your response must be concise. -2.63e+09. What is the difference between the Cost (current US$) in CO2 damage in 1990 and the Cost (current US$) in Forest in 1993?
Offer a terse response. 5.59e+07. What is the difference between the Cost (current US$) in Minerals in 1990 and the Cost (current US$) in Energy in 1993?
Your response must be concise. -2.67e+09. What is the difference between the Cost (current US$) in Minerals in 1990 and the Cost (current US$) in Forest in 1993?
Offer a very short reply. 9.71e+06. What is the difference between the Cost (current US$) of Energy in 1990 and the Cost (current US$) of Forest in 1993?
Keep it short and to the point. 3.47e+09. What is the difference between the Cost (current US$) in CO2 damage in 1991 and the Cost (current US$) in Minerals in 1992?
Ensure brevity in your answer.  5.39e+07. What is the difference between the Cost (current US$) in CO2 damage in 1991 and the Cost (current US$) in Energy in 1992?
Offer a terse response. -2.86e+09. What is the difference between the Cost (current US$) in CO2 damage in 1991 and the Cost (current US$) in Forest in 1992?
Offer a terse response. 6.04e+07. What is the difference between the Cost (current US$) of Minerals in 1991 and the Cost (current US$) of Energy in 1992?
Give a very brief answer. -2.92e+09. What is the difference between the Cost (current US$) in Minerals in 1991 and the Cost (current US$) in Forest in 1992?
Offer a very short reply. 7.18e+06. What is the difference between the Cost (current US$) of Energy in 1991 and the Cost (current US$) of Forest in 1992?
Provide a short and direct response. 2.97e+09. What is the difference between the Cost (current US$) in CO2 damage in 1991 and the Cost (current US$) in Minerals in 1993?
Your answer should be very brief. 5.83e+07. What is the difference between the Cost (current US$) in CO2 damage in 1991 and the Cost (current US$) in Energy in 1993?
Offer a very short reply. -2.62e+09. What is the difference between the Cost (current US$) in CO2 damage in 1991 and the Cost (current US$) in Forest in 1993?
Provide a succinct answer. 6.05e+07. What is the difference between the Cost (current US$) of Minerals in 1991 and the Cost (current US$) of Energy in 1993?
Provide a short and direct response. -2.68e+09. What is the difference between the Cost (current US$) of Minerals in 1991 and the Cost (current US$) of Forest in 1993?
Provide a succinct answer. 7.24e+06. What is the difference between the Cost (current US$) of Energy in 1991 and the Cost (current US$) of Forest in 1993?
Provide a short and direct response. 2.97e+09. What is the difference between the Cost (current US$) in CO2 damage in 1992 and the Cost (current US$) in Minerals in 1993?
Offer a very short reply. 6.21e+07. What is the difference between the Cost (current US$) in CO2 damage in 1992 and the Cost (current US$) in Energy in 1993?
Give a very brief answer. -2.62e+09. What is the difference between the Cost (current US$) of CO2 damage in 1992 and the Cost (current US$) of Forest in 1993?
Ensure brevity in your answer.  6.42e+07. What is the difference between the Cost (current US$) in Minerals in 1992 and the Cost (current US$) in Energy in 1993?
Give a very brief answer. -2.68e+09. What is the difference between the Cost (current US$) in Minerals in 1992 and the Cost (current US$) in Forest in 1993?
Give a very brief answer. 6.57e+06. What is the difference between the Cost (current US$) in Energy in 1992 and the Cost (current US$) in Forest in 1993?
Your answer should be very brief. 2.92e+09. What is the average Cost (current US$) of CO2 damage per year?
Your answer should be very brief. 5.19e+07. What is the average Cost (current US$) in Minerals per year?
Provide a short and direct response. 8.39e+06. What is the average Cost (current US$) of Energy per year?
Your answer should be very brief. 2.50e+09. What is the average Cost (current US$) of Forest per year?
Provide a short and direct response. 3.74e+05. In the year 1985, what is the difference between the Cost (current US$) in CO2 damage and Cost (current US$) in Minerals?
Make the answer very short. 3.02e+07. In the year 1985, what is the difference between the Cost (current US$) in CO2 damage and Cost (current US$) in Energy?
Offer a very short reply. -2.75e+09. In the year 1985, what is the difference between the Cost (current US$) of CO2 damage and Cost (current US$) of Forest?
Offer a very short reply. 3.45e+07. In the year 1985, what is the difference between the Cost (current US$) of Minerals and Cost (current US$) of Energy?
Your answer should be very brief. -2.78e+09. In the year 1985, what is the difference between the Cost (current US$) in Minerals and Cost (current US$) in Forest?
Make the answer very short. 4.34e+06. In the year 1985, what is the difference between the Cost (current US$) in Energy and Cost (current US$) in Forest?
Make the answer very short. 2.78e+09. In the year 1986, what is the difference between the Cost (current US$) of CO2 damage and Cost (current US$) of Minerals?
Your answer should be compact. 3.66e+07. In the year 1986, what is the difference between the Cost (current US$) in CO2 damage and Cost (current US$) in Energy?
Provide a short and direct response. -1.43e+09. In the year 1986, what is the difference between the Cost (current US$) in CO2 damage and Cost (current US$) in Forest?
Offer a terse response. 4.04e+07. In the year 1986, what is the difference between the Cost (current US$) of Minerals and Cost (current US$) of Energy?
Provide a short and direct response. -1.47e+09. In the year 1986, what is the difference between the Cost (current US$) of Minerals and Cost (current US$) of Forest?
Keep it short and to the point. 3.79e+06. In the year 1986, what is the difference between the Cost (current US$) in Energy and Cost (current US$) in Forest?
Provide a short and direct response. 1.47e+09. In the year 1987, what is the difference between the Cost (current US$) in CO2 damage and Cost (current US$) in Minerals?
Your answer should be very brief. 3.10e+07. In the year 1987, what is the difference between the Cost (current US$) of CO2 damage and Cost (current US$) of Energy?
Offer a terse response. -2.10e+09. In the year 1987, what is the difference between the Cost (current US$) in CO2 damage and Cost (current US$) in Forest?
Keep it short and to the point. 4.01e+07. In the year 1987, what is the difference between the Cost (current US$) in Minerals and Cost (current US$) in Energy?
Your answer should be compact. -2.13e+09. In the year 1987, what is the difference between the Cost (current US$) in Minerals and Cost (current US$) in Forest?
Make the answer very short. 9.08e+06. In the year 1987, what is the difference between the Cost (current US$) of Energy and Cost (current US$) of Forest?
Keep it short and to the point. 2.14e+09. In the year 1988, what is the difference between the Cost (current US$) in CO2 damage and Cost (current US$) in Minerals?
Offer a terse response. 3.13e+07. In the year 1988, what is the difference between the Cost (current US$) of CO2 damage and Cost (current US$) of Energy?
Your answer should be compact. -1.69e+09. In the year 1988, what is the difference between the Cost (current US$) of CO2 damage and Cost (current US$) of Forest?
Provide a short and direct response. 4.70e+07. In the year 1988, what is the difference between the Cost (current US$) of Minerals and Cost (current US$) of Energy?
Make the answer very short. -1.72e+09. In the year 1988, what is the difference between the Cost (current US$) of Minerals and Cost (current US$) of Forest?
Your answer should be very brief. 1.57e+07. In the year 1988, what is the difference between the Cost (current US$) in Energy and Cost (current US$) in Forest?
Provide a succinct answer. 1.73e+09. In the year 1989, what is the difference between the Cost (current US$) in CO2 damage and Cost (current US$) in Minerals?
Your response must be concise. 3.31e+07. In the year 1989, what is the difference between the Cost (current US$) in CO2 damage and Cost (current US$) in Energy?
Offer a very short reply. -2.25e+09. In the year 1989, what is the difference between the Cost (current US$) in CO2 damage and Cost (current US$) in Forest?
Your response must be concise. 4.70e+07. In the year 1989, what is the difference between the Cost (current US$) of Minerals and Cost (current US$) of Energy?
Provide a succinct answer. -2.29e+09. In the year 1989, what is the difference between the Cost (current US$) in Minerals and Cost (current US$) in Forest?
Your response must be concise. 1.39e+07. In the year 1989, what is the difference between the Cost (current US$) of Energy and Cost (current US$) of Forest?
Give a very brief answer. 2.30e+09. In the year 1990, what is the difference between the Cost (current US$) of CO2 damage and Cost (current US$) of Minerals?
Provide a succinct answer. 4.62e+07. In the year 1990, what is the difference between the Cost (current US$) in CO2 damage and Cost (current US$) in Energy?
Offer a very short reply. -3.42e+09. In the year 1990, what is the difference between the Cost (current US$) of CO2 damage and Cost (current US$) of Forest?
Keep it short and to the point. 5.58e+07. In the year 1990, what is the difference between the Cost (current US$) of Minerals and Cost (current US$) of Energy?
Your answer should be very brief. -3.46e+09. In the year 1990, what is the difference between the Cost (current US$) of Minerals and Cost (current US$) of Forest?
Your answer should be compact. 9.56e+06. In the year 1990, what is the difference between the Cost (current US$) of Energy and Cost (current US$) of Forest?
Your response must be concise. 3.47e+09. In the year 1991, what is the difference between the Cost (current US$) in CO2 damage and Cost (current US$) in Minerals?
Offer a very short reply. 5.32e+07. In the year 1991, what is the difference between the Cost (current US$) in CO2 damage and Cost (current US$) in Energy?
Provide a succinct answer. -2.91e+09. In the year 1991, what is the difference between the Cost (current US$) of CO2 damage and Cost (current US$) of Forest?
Your answer should be compact. 6.03e+07. In the year 1991, what is the difference between the Cost (current US$) of Minerals and Cost (current US$) of Energy?
Provide a short and direct response. -2.97e+09. In the year 1991, what is the difference between the Cost (current US$) of Minerals and Cost (current US$) of Forest?
Your answer should be very brief. 7.07e+06. In the year 1991, what is the difference between the Cost (current US$) in Energy and Cost (current US$) in Forest?
Your response must be concise. 2.97e+09. In the year 1992, what is the difference between the Cost (current US$) in CO2 damage and Cost (current US$) in Minerals?
Provide a short and direct response. 5.77e+07. In the year 1992, what is the difference between the Cost (current US$) of CO2 damage and Cost (current US$) of Energy?
Make the answer very short. -2.86e+09. In the year 1992, what is the difference between the Cost (current US$) in CO2 damage and Cost (current US$) in Forest?
Provide a short and direct response. 6.42e+07. In the year 1992, what is the difference between the Cost (current US$) of Minerals and Cost (current US$) of Energy?
Provide a short and direct response. -2.92e+09. In the year 1992, what is the difference between the Cost (current US$) of Minerals and Cost (current US$) of Forest?
Provide a short and direct response. 6.51e+06. In the year 1992, what is the difference between the Cost (current US$) of Energy and Cost (current US$) of Forest?
Provide a short and direct response. 2.92e+09. In the year 1993, what is the difference between the Cost (current US$) of CO2 damage and Cost (current US$) of Minerals?
Ensure brevity in your answer.  7.20e+07. In the year 1993, what is the difference between the Cost (current US$) in CO2 damage and Cost (current US$) in Energy?
Your answer should be very brief. -2.61e+09. In the year 1993, what is the difference between the Cost (current US$) of CO2 damage and Cost (current US$) of Forest?
Offer a terse response. 7.42e+07. In the year 1993, what is the difference between the Cost (current US$) of Minerals and Cost (current US$) of Energy?
Your answer should be compact. -2.68e+09. In the year 1993, what is the difference between the Cost (current US$) in Minerals and Cost (current US$) in Forest?
Your answer should be compact. 2.18e+06. In the year 1993, what is the difference between the Cost (current US$) in Energy and Cost (current US$) in Forest?
Keep it short and to the point. 2.68e+09. What is the ratio of the Cost (current US$) of CO2 damage in 1985 to that in 1986?
Your response must be concise. 0.85. What is the ratio of the Cost (current US$) in Minerals in 1985 to that in 1986?
Provide a succinct answer. 1.07. What is the ratio of the Cost (current US$) in Energy in 1985 to that in 1986?
Give a very brief answer. 1.89. What is the ratio of the Cost (current US$) of Forest in 1985 to that in 1986?
Your answer should be compact. 0.33. What is the ratio of the Cost (current US$) in CO2 damage in 1985 to that in 1987?
Your answer should be compact. 0.85. What is the ratio of the Cost (current US$) of Minerals in 1985 to that in 1987?
Provide a short and direct response. 0.47. What is the ratio of the Cost (current US$) in Energy in 1985 to that in 1987?
Your answer should be very brief. 1.3. What is the ratio of the Cost (current US$) of Forest in 1985 to that in 1987?
Your answer should be compact. 0.3. What is the ratio of the Cost (current US$) of CO2 damage in 1985 to that in 1988?
Offer a terse response. 0.73. What is the ratio of the Cost (current US$) in Minerals in 1985 to that in 1988?
Keep it short and to the point. 0.28. What is the ratio of the Cost (current US$) of Energy in 1985 to that in 1988?
Ensure brevity in your answer.  1.6. What is the ratio of the Cost (current US$) in Forest in 1985 to that in 1988?
Keep it short and to the point. 0.28. What is the ratio of the Cost (current US$) in CO2 damage in 1985 to that in 1989?
Provide a short and direct response. 0.73. What is the ratio of the Cost (current US$) of Minerals in 1985 to that in 1989?
Offer a very short reply. 0.31. What is the ratio of the Cost (current US$) in Energy in 1985 to that in 1989?
Your response must be concise. 1.21. What is the ratio of the Cost (current US$) of Forest in 1985 to that in 1989?
Provide a short and direct response. 0.26. What is the ratio of the Cost (current US$) in CO2 damage in 1985 to that in 1990?
Make the answer very short. 0.62. What is the ratio of the Cost (current US$) of Minerals in 1985 to that in 1990?
Make the answer very short. 0.44. What is the ratio of the Cost (current US$) in Energy in 1985 to that in 1990?
Your response must be concise. 0.8. What is the ratio of the Cost (current US$) of Forest in 1985 to that in 1990?
Give a very brief answer. 0.25. What is the ratio of the Cost (current US$) of CO2 damage in 1985 to that in 1991?
Give a very brief answer. 0.57. What is the ratio of the Cost (current US$) in Minerals in 1985 to that in 1991?
Provide a short and direct response. 0.59. What is the ratio of the Cost (current US$) of Energy in 1985 to that in 1991?
Make the answer very short. 0.94. What is the ratio of the Cost (current US$) in Forest in 1985 to that in 1991?
Your answer should be compact. 0.23. What is the ratio of the Cost (current US$) in CO2 damage in 1985 to that in 1992?
Offer a very short reply. 0.54. What is the ratio of the Cost (current US$) of Minerals in 1985 to that in 1992?
Provide a short and direct response. 0.65. What is the ratio of the Cost (current US$) of Energy in 1985 to that in 1992?
Your answer should be very brief. 0.95. What is the ratio of the Cost (current US$) of Forest in 1985 to that in 1992?
Make the answer very short. 0.3. What is the ratio of the Cost (current US$) in CO2 damage in 1985 to that in 1993?
Give a very brief answer. 0.46. What is the ratio of the Cost (current US$) of Minerals in 1985 to that in 1993?
Make the answer very short. 1.78. What is the ratio of the Cost (current US$) in Energy in 1985 to that in 1993?
Give a very brief answer. 1.04. What is the ratio of the Cost (current US$) in Forest in 1985 to that in 1993?
Offer a terse response. 0.35. What is the ratio of the Cost (current US$) in CO2 damage in 1986 to that in 1987?
Your response must be concise. 1.01. What is the ratio of the Cost (current US$) of Minerals in 1986 to that in 1987?
Ensure brevity in your answer.  0.44. What is the ratio of the Cost (current US$) in Energy in 1986 to that in 1987?
Keep it short and to the point. 0.69. What is the ratio of the Cost (current US$) of Forest in 1986 to that in 1987?
Your answer should be very brief. 0.92. What is the ratio of the Cost (current US$) of CO2 damage in 1986 to that in 1988?
Offer a very short reply. 0.86. What is the ratio of the Cost (current US$) of Minerals in 1986 to that in 1988?
Keep it short and to the point. 0.26. What is the ratio of the Cost (current US$) in Energy in 1986 to that in 1988?
Your answer should be compact. 0.85. What is the ratio of the Cost (current US$) of Forest in 1986 to that in 1988?
Ensure brevity in your answer.  0.86. What is the ratio of the Cost (current US$) of CO2 damage in 1986 to that in 1989?
Ensure brevity in your answer.  0.86. What is the ratio of the Cost (current US$) of Minerals in 1986 to that in 1989?
Ensure brevity in your answer.  0.29. What is the ratio of the Cost (current US$) of Energy in 1986 to that in 1989?
Offer a very short reply. 0.64. What is the ratio of the Cost (current US$) in Forest in 1986 to that in 1989?
Provide a succinct answer. 0.8. What is the ratio of the Cost (current US$) in CO2 damage in 1986 to that in 1990?
Make the answer very short. 0.72. What is the ratio of the Cost (current US$) in Minerals in 1986 to that in 1990?
Your response must be concise. 0.41. What is the ratio of the Cost (current US$) in Energy in 1986 to that in 1990?
Make the answer very short. 0.42. What is the ratio of the Cost (current US$) of Forest in 1986 to that in 1990?
Provide a succinct answer. 0.75. What is the ratio of the Cost (current US$) of CO2 damage in 1986 to that in 1991?
Make the answer very short. 0.67. What is the ratio of the Cost (current US$) of Minerals in 1986 to that in 1991?
Offer a very short reply. 0.55. What is the ratio of the Cost (current US$) of Energy in 1986 to that in 1991?
Provide a succinct answer. 0.49. What is the ratio of the Cost (current US$) of Forest in 1986 to that in 1991?
Offer a very short reply. 0.72. What is the ratio of the Cost (current US$) in CO2 damage in 1986 to that in 1992?
Your response must be concise. 0.63. What is the ratio of the Cost (current US$) of Minerals in 1986 to that in 1992?
Keep it short and to the point. 0.6. What is the ratio of the Cost (current US$) of Energy in 1986 to that in 1992?
Your answer should be compact. 0.5. What is the ratio of the Cost (current US$) of Forest in 1986 to that in 1992?
Your response must be concise. 0.93. What is the ratio of the Cost (current US$) in CO2 damage in 1986 to that in 1993?
Your response must be concise. 0.55. What is the ratio of the Cost (current US$) of Minerals in 1986 to that in 1993?
Offer a very short reply. 1.66. What is the ratio of the Cost (current US$) of Energy in 1986 to that in 1993?
Keep it short and to the point. 0.55. What is the ratio of the Cost (current US$) of Forest in 1986 to that in 1993?
Ensure brevity in your answer.  1.08. What is the ratio of the Cost (current US$) of CO2 damage in 1987 to that in 1988?
Provide a succinct answer. 0.85. What is the ratio of the Cost (current US$) in Minerals in 1987 to that in 1988?
Your response must be concise. 0.59. What is the ratio of the Cost (current US$) of Energy in 1987 to that in 1988?
Keep it short and to the point. 1.23. What is the ratio of the Cost (current US$) in Forest in 1987 to that in 1988?
Your answer should be compact. 0.94. What is the ratio of the Cost (current US$) in CO2 damage in 1987 to that in 1989?
Your answer should be compact. 0.85. What is the ratio of the Cost (current US$) of Minerals in 1987 to that in 1989?
Ensure brevity in your answer.  0.66. What is the ratio of the Cost (current US$) of Energy in 1987 to that in 1989?
Offer a very short reply. 0.93. What is the ratio of the Cost (current US$) of Forest in 1987 to that in 1989?
Provide a short and direct response. 0.88. What is the ratio of the Cost (current US$) of CO2 damage in 1987 to that in 1990?
Offer a very short reply. 0.72. What is the ratio of the Cost (current US$) in Minerals in 1987 to that in 1990?
Make the answer very short. 0.94. What is the ratio of the Cost (current US$) of Energy in 1987 to that in 1990?
Provide a short and direct response. 0.62. What is the ratio of the Cost (current US$) of Forest in 1987 to that in 1990?
Ensure brevity in your answer.  0.82. What is the ratio of the Cost (current US$) of CO2 damage in 1987 to that in 1991?
Your answer should be compact. 0.67. What is the ratio of the Cost (current US$) of Minerals in 1987 to that in 1991?
Your response must be concise. 1.25. What is the ratio of the Cost (current US$) of Energy in 1987 to that in 1991?
Provide a short and direct response. 0.72. What is the ratio of the Cost (current US$) in Forest in 1987 to that in 1991?
Make the answer very short. 0.78. What is the ratio of the Cost (current US$) in CO2 damage in 1987 to that in 1992?
Keep it short and to the point. 0.63. What is the ratio of the Cost (current US$) in Minerals in 1987 to that in 1992?
Offer a terse response. 1.37. What is the ratio of the Cost (current US$) of Energy in 1987 to that in 1992?
Provide a short and direct response. 0.73. What is the ratio of the Cost (current US$) in Forest in 1987 to that in 1992?
Keep it short and to the point. 1.02. What is the ratio of the Cost (current US$) in CO2 damage in 1987 to that in 1993?
Your answer should be compact. 0.54. What is the ratio of the Cost (current US$) in Minerals in 1987 to that in 1993?
Offer a terse response. 3.78. What is the ratio of the Cost (current US$) of Energy in 1987 to that in 1993?
Give a very brief answer. 0.8. What is the ratio of the Cost (current US$) of Forest in 1987 to that in 1993?
Your answer should be compact. 1.18. What is the ratio of the Cost (current US$) in CO2 damage in 1988 to that in 1989?
Offer a terse response. 1. What is the ratio of the Cost (current US$) in Minerals in 1988 to that in 1989?
Offer a very short reply. 1.13. What is the ratio of the Cost (current US$) in Energy in 1988 to that in 1989?
Offer a terse response. 0.75. What is the ratio of the Cost (current US$) in Forest in 1988 to that in 1989?
Your answer should be very brief. 0.93. What is the ratio of the Cost (current US$) in CO2 damage in 1988 to that in 1990?
Your answer should be compact. 0.84. What is the ratio of the Cost (current US$) of Minerals in 1988 to that in 1990?
Give a very brief answer. 1.61. What is the ratio of the Cost (current US$) in Energy in 1988 to that in 1990?
Your answer should be very brief. 0.5. What is the ratio of the Cost (current US$) of Forest in 1988 to that in 1990?
Ensure brevity in your answer.  0.88. What is the ratio of the Cost (current US$) in CO2 damage in 1988 to that in 1991?
Your answer should be compact. 0.78. What is the ratio of the Cost (current US$) of Minerals in 1988 to that in 1991?
Make the answer very short. 2.13. What is the ratio of the Cost (current US$) of Energy in 1988 to that in 1991?
Make the answer very short. 0.58. What is the ratio of the Cost (current US$) of Forest in 1988 to that in 1991?
Offer a very short reply. 0.83. What is the ratio of the Cost (current US$) in CO2 damage in 1988 to that in 1992?
Keep it short and to the point. 0.73. What is the ratio of the Cost (current US$) of Minerals in 1988 to that in 1992?
Keep it short and to the point. 2.34. What is the ratio of the Cost (current US$) in Energy in 1988 to that in 1992?
Give a very brief answer. 0.59. What is the ratio of the Cost (current US$) of Forest in 1988 to that in 1992?
Provide a short and direct response. 1.08. What is the ratio of the Cost (current US$) in CO2 damage in 1988 to that in 1993?
Your answer should be very brief. 0.64. What is the ratio of the Cost (current US$) of Minerals in 1988 to that in 1993?
Offer a very short reply. 6.45. What is the ratio of the Cost (current US$) of Energy in 1988 to that in 1993?
Ensure brevity in your answer.  0.65. What is the ratio of the Cost (current US$) in Forest in 1988 to that in 1993?
Give a very brief answer. 1.25. What is the ratio of the Cost (current US$) of CO2 damage in 1989 to that in 1990?
Provide a short and direct response. 0.84. What is the ratio of the Cost (current US$) of Minerals in 1989 to that in 1990?
Offer a very short reply. 1.43. What is the ratio of the Cost (current US$) of Energy in 1989 to that in 1990?
Your answer should be very brief. 0.66. What is the ratio of the Cost (current US$) of Forest in 1989 to that in 1990?
Your answer should be very brief. 0.94. What is the ratio of the Cost (current US$) in CO2 damage in 1989 to that in 1991?
Offer a very short reply. 0.78. What is the ratio of the Cost (current US$) of Minerals in 1989 to that in 1991?
Your answer should be compact. 1.9. What is the ratio of the Cost (current US$) of Energy in 1989 to that in 1991?
Your answer should be very brief. 0.77. What is the ratio of the Cost (current US$) in Forest in 1989 to that in 1991?
Provide a short and direct response. 0.9. What is the ratio of the Cost (current US$) of CO2 damage in 1989 to that in 1992?
Make the answer very short. 0.73. What is the ratio of the Cost (current US$) of Minerals in 1989 to that in 1992?
Your answer should be very brief. 2.08. What is the ratio of the Cost (current US$) of Energy in 1989 to that in 1992?
Provide a succinct answer. 0.79. What is the ratio of the Cost (current US$) of Forest in 1989 to that in 1992?
Offer a very short reply. 1.16. What is the ratio of the Cost (current US$) in CO2 damage in 1989 to that in 1993?
Make the answer very short. 0.64. What is the ratio of the Cost (current US$) in Minerals in 1989 to that in 1993?
Provide a succinct answer. 5.73. What is the ratio of the Cost (current US$) of Energy in 1989 to that in 1993?
Offer a terse response. 0.86. What is the ratio of the Cost (current US$) in Forest in 1989 to that in 1993?
Offer a terse response. 1.34. What is the ratio of the Cost (current US$) of CO2 damage in 1990 to that in 1991?
Your answer should be very brief. 0.93. What is the ratio of the Cost (current US$) in Minerals in 1990 to that in 1991?
Keep it short and to the point. 1.33. What is the ratio of the Cost (current US$) in Energy in 1990 to that in 1991?
Offer a terse response. 1.17. What is the ratio of the Cost (current US$) of Forest in 1990 to that in 1991?
Offer a very short reply. 0.95. What is the ratio of the Cost (current US$) of CO2 damage in 1990 to that in 1992?
Keep it short and to the point. 0.87. What is the ratio of the Cost (current US$) of Minerals in 1990 to that in 1992?
Your answer should be compact. 1.46. What is the ratio of the Cost (current US$) of Energy in 1990 to that in 1992?
Your answer should be very brief. 1.19. What is the ratio of the Cost (current US$) of Forest in 1990 to that in 1992?
Your answer should be compact. 1.24. What is the ratio of the Cost (current US$) in CO2 damage in 1990 to that in 1993?
Provide a succinct answer. 0.76. What is the ratio of the Cost (current US$) in Minerals in 1990 to that in 1993?
Your answer should be very brief. 4.01. What is the ratio of the Cost (current US$) in Energy in 1990 to that in 1993?
Offer a terse response. 1.29. What is the ratio of the Cost (current US$) in Forest in 1990 to that in 1993?
Give a very brief answer. 1.43. What is the ratio of the Cost (current US$) of CO2 damage in 1991 to that in 1992?
Give a very brief answer. 0.94. What is the ratio of the Cost (current US$) of Minerals in 1991 to that in 1992?
Your response must be concise. 1.1. What is the ratio of the Cost (current US$) in Energy in 1991 to that in 1992?
Your answer should be compact. 1.02. What is the ratio of the Cost (current US$) of Forest in 1991 to that in 1992?
Give a very brief answer. 1.3. What is the ratio of the Cost (current US$) in CO2 damage in 1991 to that in 1993?
Ensure brevity in your answer.  0.82. What is the ratio of the Cost (current US$) in Minerals in 1991 to that in 1993?
Give a very brief answer. 3.02. What is the ratio of the Cost (current US$) in Energy in 1991 to that in 1993?
Offer a very short reply. 1.11. What is the ratio of the Cost (current US$) of Forest in 1991 to that in 1993?
Give a very brief answer. 1.5. What is the ratio of the Cost (current US$) in CO2 damage in 1992 to that in 1993?
Offer a very short reply. 0.87. What is the ratio of the Cost (current US$) in Minerals in 1992 to that in 1993?
Give a very brief answer. 2.75. What is the ratio of the Cost (current US$) in Energy in 1992 to that in 1993?
Give a very brief answer. 1.09. What is the ratio of the Cost (current US$) in Forest in 1992 to that in 1993?
Make the answer very short. 1.16. What is the difference between the highest and the second highest Cost (current US$) of CO2 damage?
Keep it short and to the point. 9.95e+06. What is the difference between the highest and the second highest Cost (current US$) of Minerals?
Your response must be concise. 1.80e+06. What is the difference between the highest and the second highest Cost (current US$) in Energy?
Offer a terse response. 5.01e+08. What is the difference between the highest and the second highest Cost (current US$) of Forest?
Offer a terse response. 2.31e+04. What is the difference between the highest and the lowest Cost (current US$) of CO2 damage?
Make the answer very short. 3.99e+07. What is the difference between the highest and the lowest Cost (current US$) in Minerals?
Provide a succinct answer. 1.36e+07. What is the difference between the highest and the lowest Cost (current US$) of Energy?
Offer a very short reply. 2.01e+09. What is the difference between the highest and the lowest Cost (current US$) in Forest?
Offer a terse response. 3.76e+05. 